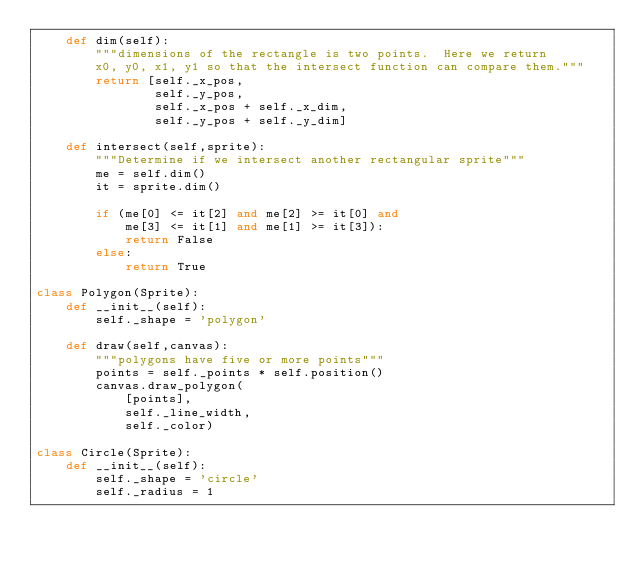<code> <loc_0><loc_0><loc_500><loc_500><_Python_>    def dim(self):
        """dimensions of the rectangle is two points.  Here we return 
        x0, y0, x1, y1 so that the intersect function can compare them."""
        return [self._x_pos, 
                self._y_pos,
                self._x_pos + self._x_dim,
                self._y_pos + self._y_dim]
    
    def intersect(self,sprite):
        """Determine if we intersect another rectangular sprite"""
        me = self.dim()
        it = sprite.dim()
        
        if (me[0] <= it[2] and me[2] >= it[0] and
            me[3] <= it[1] and me[1] >= it[3]):
            return False
        else:
            return True
        
class Polygon(Sprite):
    def __init__(self):
        self._shape = 'polygon'
    
    def draw(self,canvas):
        """polygons have five or more points"""
        points = self._points * self.position()
        canvas.draw_polygon(
            [points],
            self._line_width,
            self._color)
      
class Circle(Sprite):
    def __init__(self):
        self._shape = 'circle'
        self._radius = 1
</code> 